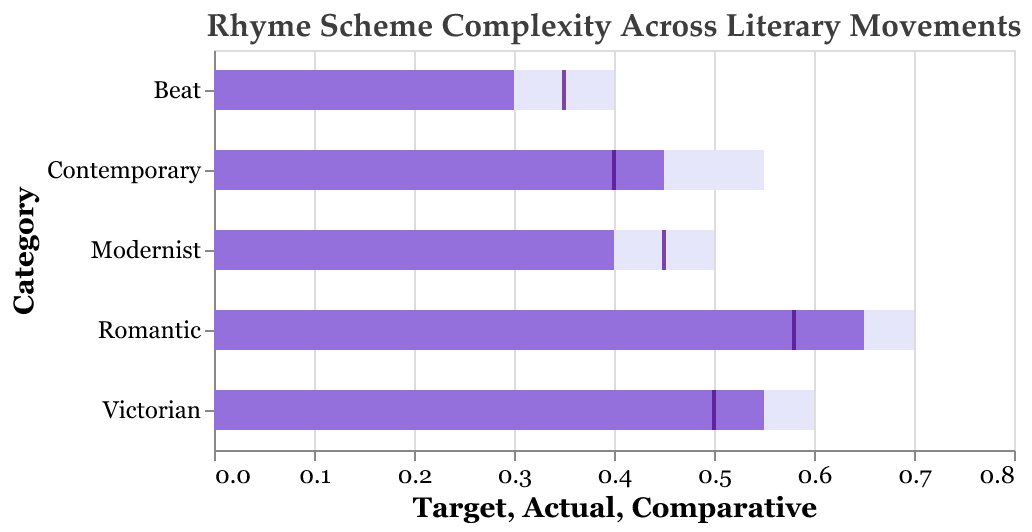How many literary movements are compared in the chart? The visual shows multiple bars each corresponding to a different literary movement, we can count those categories to determine the number of movements compared in the figure.
Answer: 5 Which literary movement has the highest actual value for rhyme scheme complexity? By looking at the bar representing the "Actual" value, the highest bar belongs to the Romantic literary movement.
Answer: Romantic What is the target value for the rhyme scheme complexity in the Contemporary category? The lightest colored (background) bar depicts the target value, and for Contemporary, this value appears to be at the 0.55 mark.
Answer: 0.55 Which literary movement's actual rhyme scheme complexity falls short of its target by the smallest margin? We compare the difference between the actual and target values for each movement: 
- Romantic: 0.70 - 0.65 = 0.05 
- Victorian: 0.60 - 0.55 = 0.05 
- Modernist: 0.50 - 0.40 = 0.10 
- Beat: 0.40 - 0.30 = 0.10 
- Contemporary: 0.55 - 0.45 = 0.10 
Romantic and Victorian both fall short by the smallest margin of 0.05.
Answer: Romantic and Victorian How does the comparative value for Modernist compare to its actual and target values? The "Comparative" value (tick) for Modernist is at 0.45, the actual value (darker bar) is at 0.40, and the target value (lightest bar) is at 0.50. So, the comparative value is higher than the actual but lower than the target.
Answer: Higher than actual, lower than target Which movement has the smallest difference between its comparative and actual values? By comparing the differences for each movement: 
- Romantic: 0.65 - 0.58 = 0.07 
- Victorian: 0.55 - 0.50 = 0.05 
- Modernist: 0.40 - 0.45 = -0.05 
- Beat: 0.30 - 0.35 = -0.05 
- Contemporary: 0.45 - 0.40 = 0.05 
Modernist and Beat have the smallest difference of -0.05.
Answer: Modernist and Beat What is the average target value across all the literary movements? Calculate the sum of all target values and divide by the number of movements: 0.70 + 0.60 + 0.50 + 0.40 + 0.55 = 2.75, and there are 5 movements, so 2.75 / 5 = 0.55
Answer: 0.55 